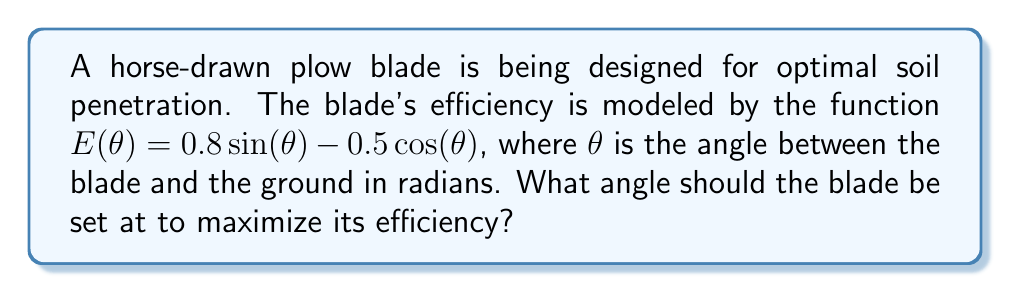Solve this math problem. To find the optimal angle, we need to maximize the efficiency function $E(\theta)$. We can do this by finding the angle where the derivative of $E(\theta)$ equals zero.

Step 1: Find the derivative of $E(\theta)$
$$E'(\theta) = 0.8\cos(\theta) + 0.5\sin(\theta)$$

Step 2: Set the derivative equal to zero and solve for $\theta$
$$0.8\cos(\theta) + 0.5\sin(\theta) = 0$$

Step 3: Divide both sides by $\cos(\theta)$ (assuming $\cos(\theta) \neq 0$)
$$0.8 + 0.5\tan(\theta) = 0$$

Step 4: Solve for $\tan(\theta)$
$$\tan(\theta) = -\frac{0.8}{0.5} = -1.6$$

Step 5: Take the inverse tangent (arctangent) of both sides
$$\theta = \arctan(-1.6)$$

Step 6: Convert the result to degrees
$$\theta \approx -58.0° \text{ or } 122.0°$$

Since we're looking for a positive angle between the blade and the ground, we choose the positive solution.

Step 7: Verify this is a maximum by checking the second derivative
$$E''(\theta) = -0.8\sin(\theta) + 0.5\cos(\theta)$$
At $\theta \approx 122.0°$, $E''(\theta) < 0$, confirming it's a maximum.
Answer: $122.0°$ 